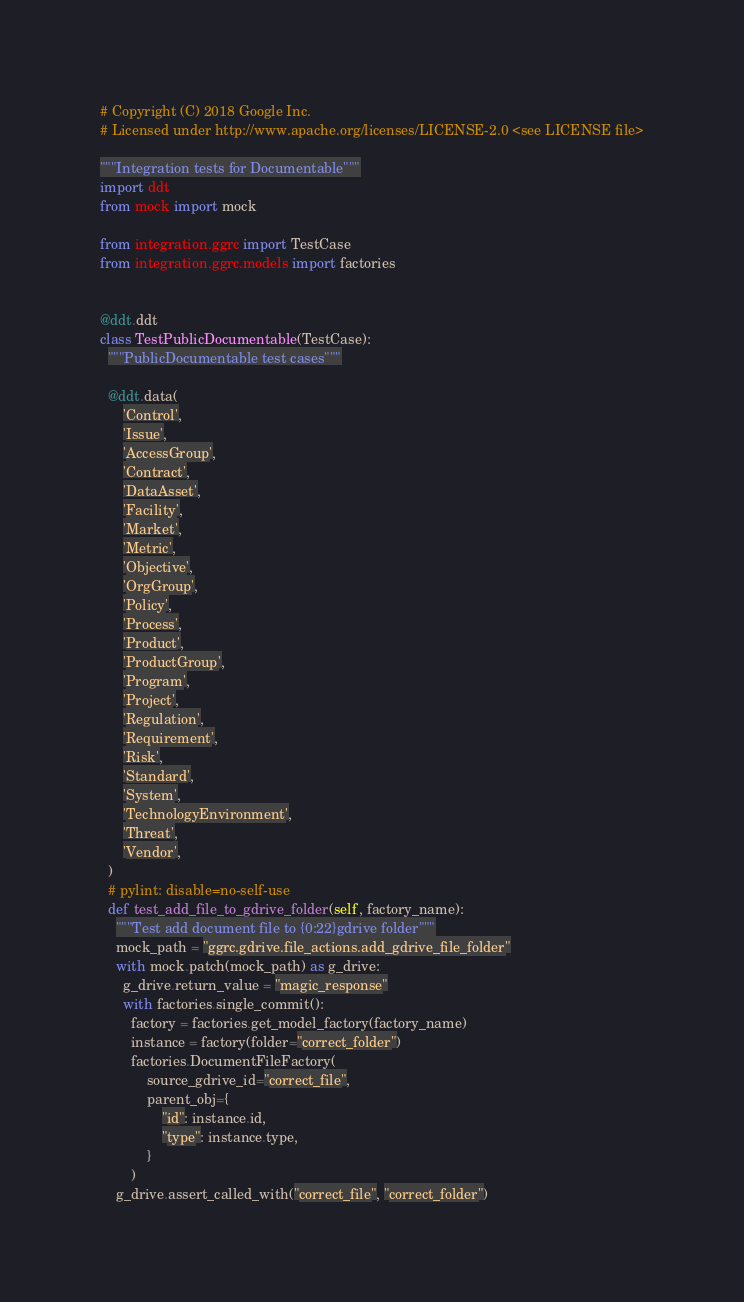<code> <loc_0><loc_0><loc_500><loc_500><_Python_># Copyright (C) 2018 Google Inc.
# Licensed under http://www.apache.org/licenses/LICENSE-2.0 <see LICENSE file>

"""Integration tests for Documentable"""
import ddt
from mock import mock

from integration.ggrc import TestCase
from integration.ggrc.models import factories


@ddt.ddt
class TestPublicDocumentable(TestCase):
  """PublicDocumentable test cases"""

  @ddt.data(
      'Control',
      'Issue',
      'AccessGroup',
      'Contract',
      'DataAsset',
      'Facility',
      'Market',
      'Metric',
      'Objective',
      'OrgGroup',
      'Policy',
      'Process',
      'Product',
      'ProductGroup',
      'Program',
      'Project',
      'Regulation',
      'Requirement',
      'Risk',
      'Standard',
      'System',
      'TechnologyEnvironment',
      'Threat',
      'Vendor',
  )
  # pylint: disable=no-self-use
  def test_add_file_to_gdrive_folder(self, factory_name):
    """Test add document file to {0:22}gdrive folder"""
    mock_path = "ggrc.gdrive.file_actions.add_gdrive_file_folder"
    with mock.patch(mock_path) as g_drive:
      g_drive.return_value = "magic_response"
      with factories.single_commit():
        factory = factories.get_model_factory(factory_name)
        instance = factory(folder="correct_folder")
        factories.DocumentFileFactory(
            source_gdrive_id="correct_file",
            parent_obj={
                "id": instance.id,
                "type": instance.type,
            }
        )
    g_drive.assert_called_with("correct_file", "correct_folder")
</code> 